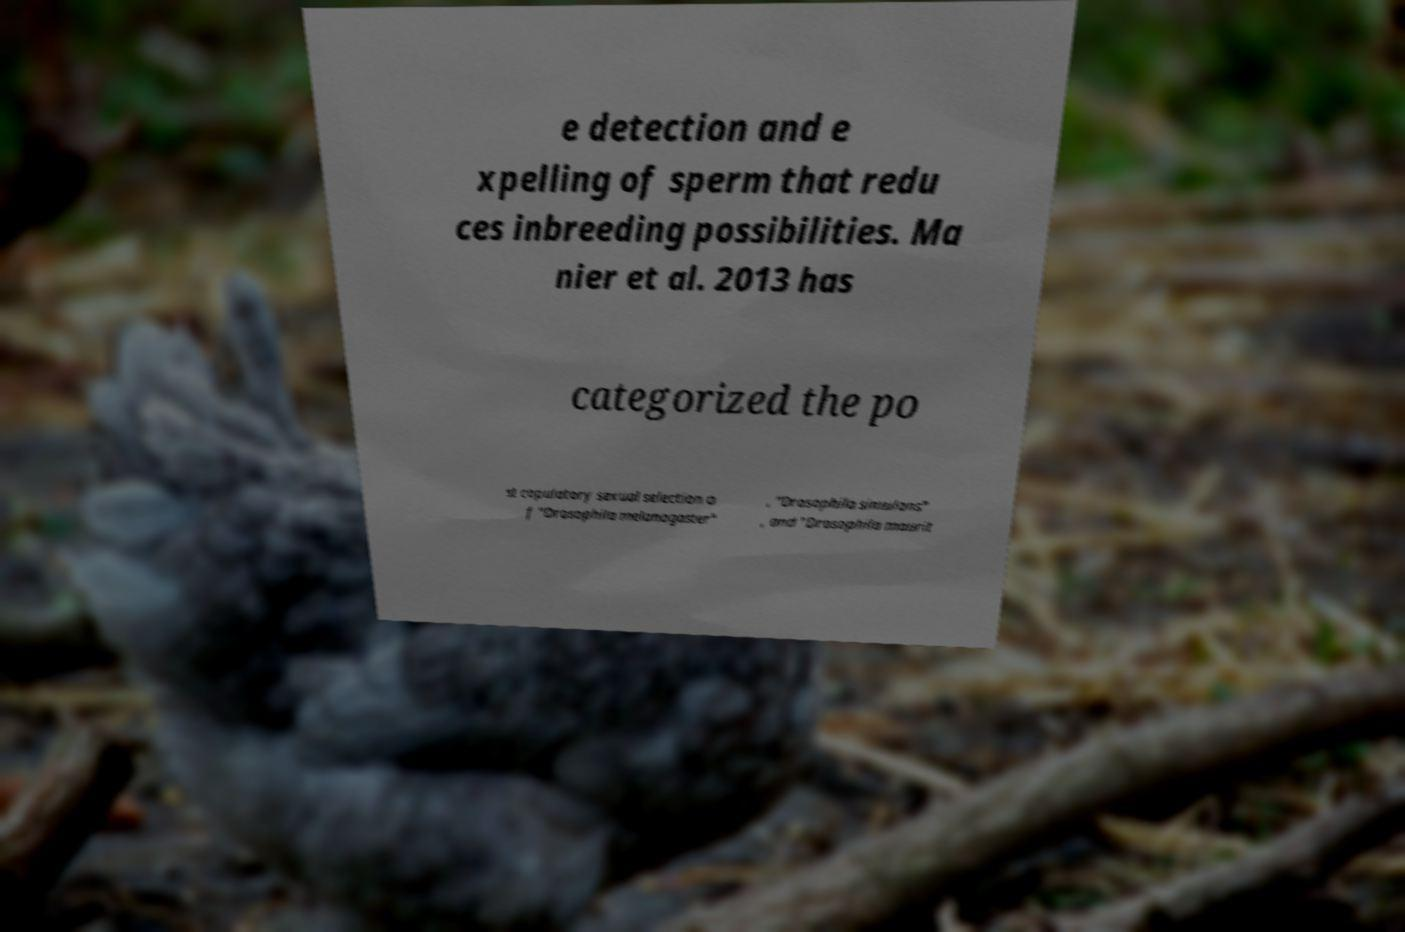I need the written content from this picture converted into text. Can you do that? e detection and e xpelling of sperm that redu ces inbreeding possibilities. Ma nier et al. 2013 has categorized the po st copulatory sexual selection o f "Drosophila melanogaster" , "Drosophila simulans" , and "Drosophila maurit 